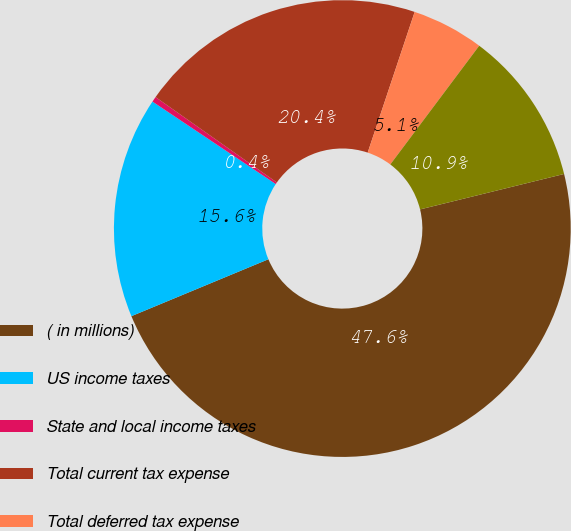Convert chart. <chart><loc_0><loc_0><loc_500><loc_500><pie_chart><fcel>( in millions)<fcel>US income taxes<fcel>State and local income taxes<fcel>Total current tax expense<fcel>Total deferred tax expense<fcel>Applicable income tax expense<nl><fcel>47.58%<fcel>15.65%<fcel>0.38%<fcel>20.37%<fcel>5.1%<fcel>10.93%<nl></chart> 